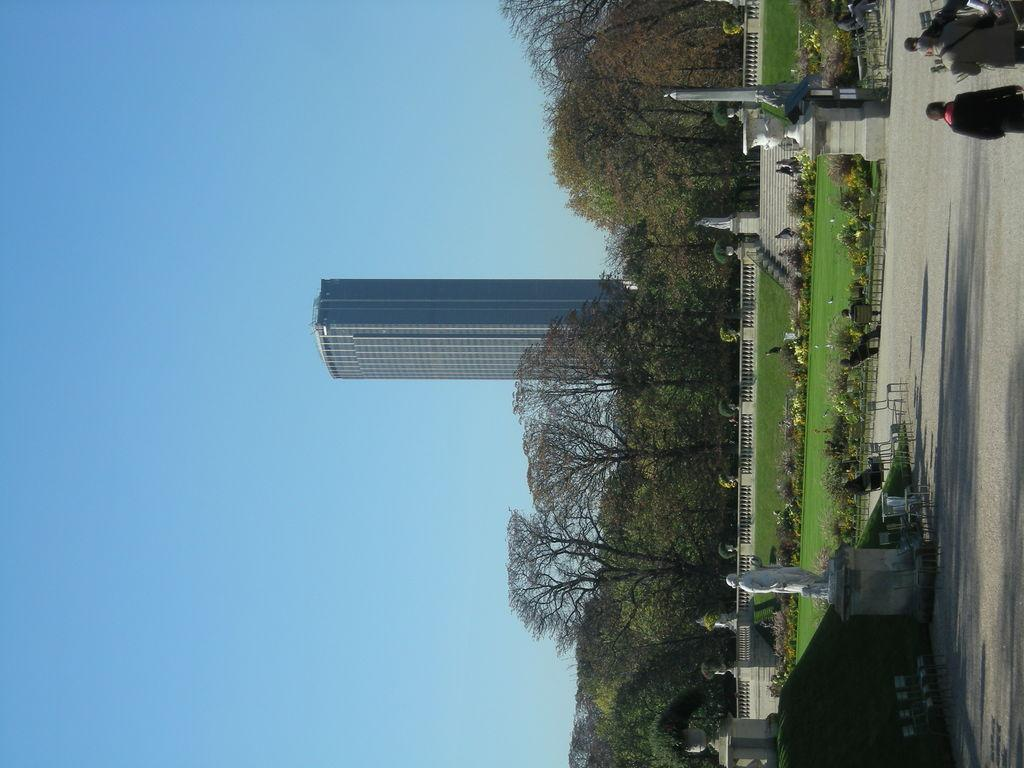What type of structures can be seen in the image? There are statues and a building in the image. What type of barrier is present in the image? There is a fence in the image. What type of vegetation is present in the image? There are trees and grass in the image. What type of surface are the people standing on in the image? The people are standing on the ground in the image. What other objects can be seen in the image besides the statues, fence, trees, and grass? There are other objects in the image. What can be seen in the background of the image? The sky is visible in the background of the image. Can you tell me how many babies are being lifted by the statues in the image? There are no babies present in the image, nor are any statues lifting anything. What type of interest is being paid to the statues by the people in the image? There is no indication of any specific interest being paid to the statues by the people in the image. 